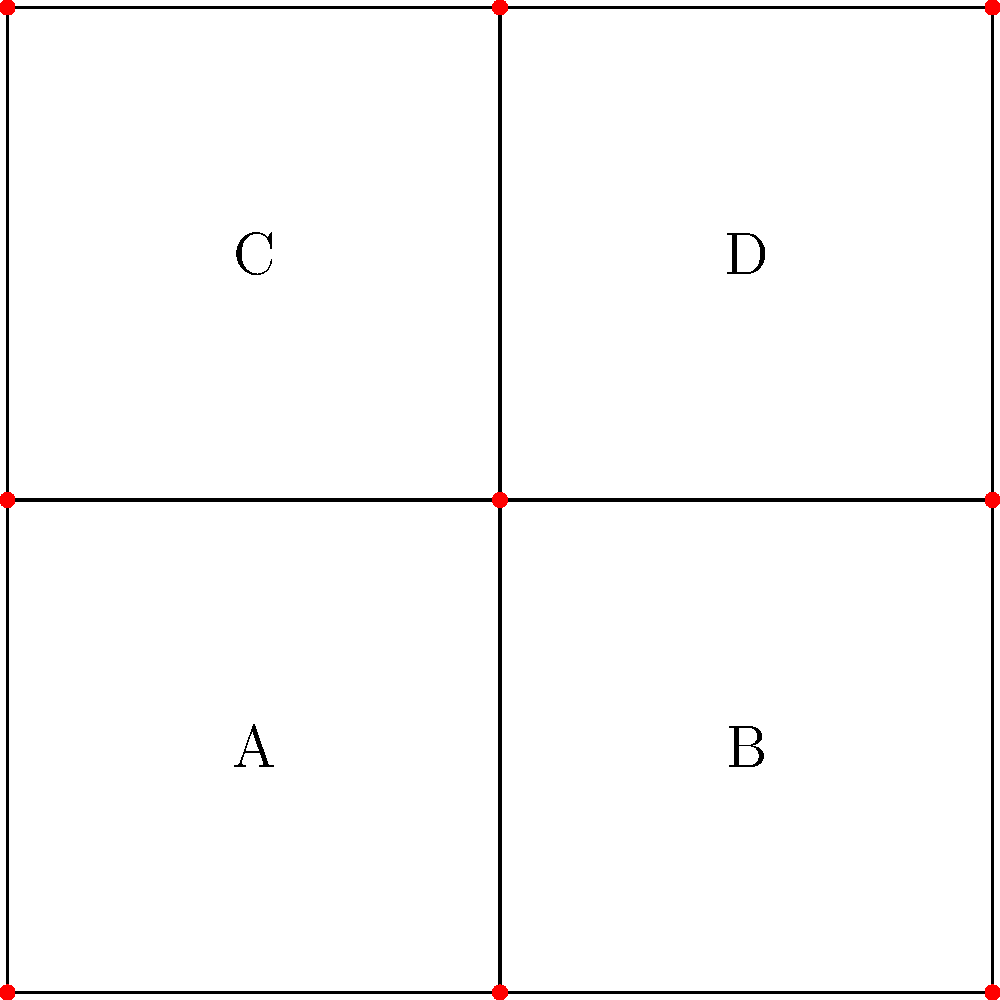As a local artist designing a stained glass window for Notre Dame, you're working on a pattern represented by the graph above. Each vertex represents an intersection of glass pieces, and each region (labeled A, B, C, and D) needs to be colored. If adjacent regions cannot share the same color, what is the minimum number of colors needed to properly color this stained glass design? To determine the minimum number of colors needed, we can follow these steps:

1. Identify adjacent regions:
   - A is adjacent to B, C, and D
   - B is adjacent to A and D
   - C is adjacent to A and D
   - D is adjacent to A, B, and C

2. Apply the graph coloring algorithm:
   - Start with region A and assign it color 1
   - Region B cannot be color 1, so assign it color 2
   - Region C cannot be color 1, so assign it color 2
   - Region D is adjacent to A (color 1), B (color 2), and C (color 2), so it needs a new color: color 3

3. Check if the coloring is valid:
   - No adjacent regions share the same color
   - We used 3 colors in total

4. Verify that 2 colors are not sufficient:
   - If we try to use only 2 colors, we would have to color A and D with one color, and B and C with another
   - However, this is impossible because A is adjacent to all other regions

Therefore, the minimum number of colors needed is 3.
Answer: 3 colors 